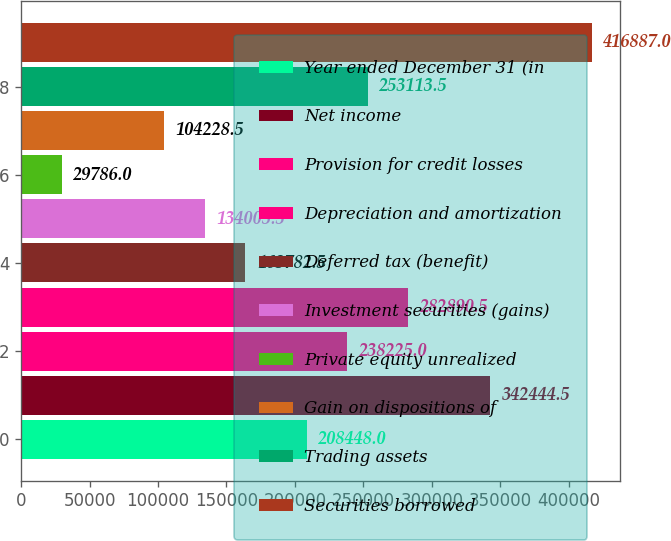Convert chart to OTSL. <chart><loc_0><loc_0><loc_500><loc_500><bar_chart><fcel>Year ended December 31 (in<fcel>Net income<fcel>Provision for credit losses<fcel>Depreciation and amortization<fcel>Deferred tax (benefit)<fcel>Investment securities (gains)<fcel>Private equity unrealized<fcel>Gain on dispositions of<fcel>Trading assets<fcel>Securities borrowed<nl><fcel>208448<fcel>342444<fcel>238225<fcel>282890<fcel>163782<fcel>134006<fcel>29786<fcel>104228<fcel>253114<fcel>416887<nl></chart> 